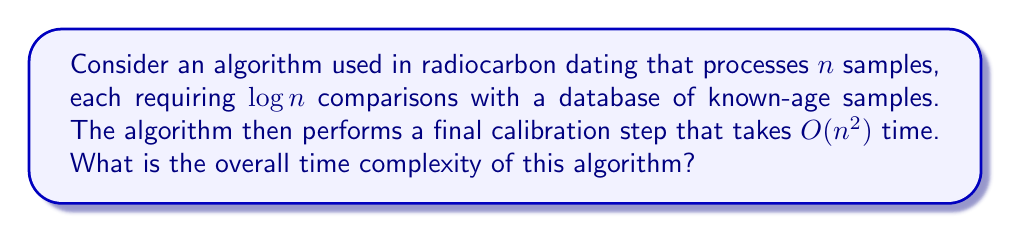What is the answer to this math problem? To determine the overall time complexity of this algorithm, we need to analyze its components and combine them:

1. Processing $n$ samples:
   - Each sample requires $\log n$ comparisons
   - Total time for this step: $n \cdot \log n = O(n \log n)$

2. Final calibration step:
   - This step takes $O(n^2)$ time

To find the overall time complexity, we need to add these components:

$$O(n \log n) + O(n^2)$$

When adding time complexities, we keep the dominant (slower-growing) term. To compare $n \log n$ and $n^2$, we can observe that:

$$\lim_{n \to \infty} \frac{n \log n}{n^2} = \lim_{n \to \infty} \frac{\log n}{n} = 0$$

This limit approaching 0 indicates that $n^2$ grows faster than $n \log n$ as $n$ increases.

Therefore, the $O(n^2)$ term dominates, and we can simplify the overall time complexity to:

$$O(n^2)$$

This means that for large inputs, the quadratic calibration step becomes the bottleneck in the algorithm's performance.
Answer: $O(n^2)$ 